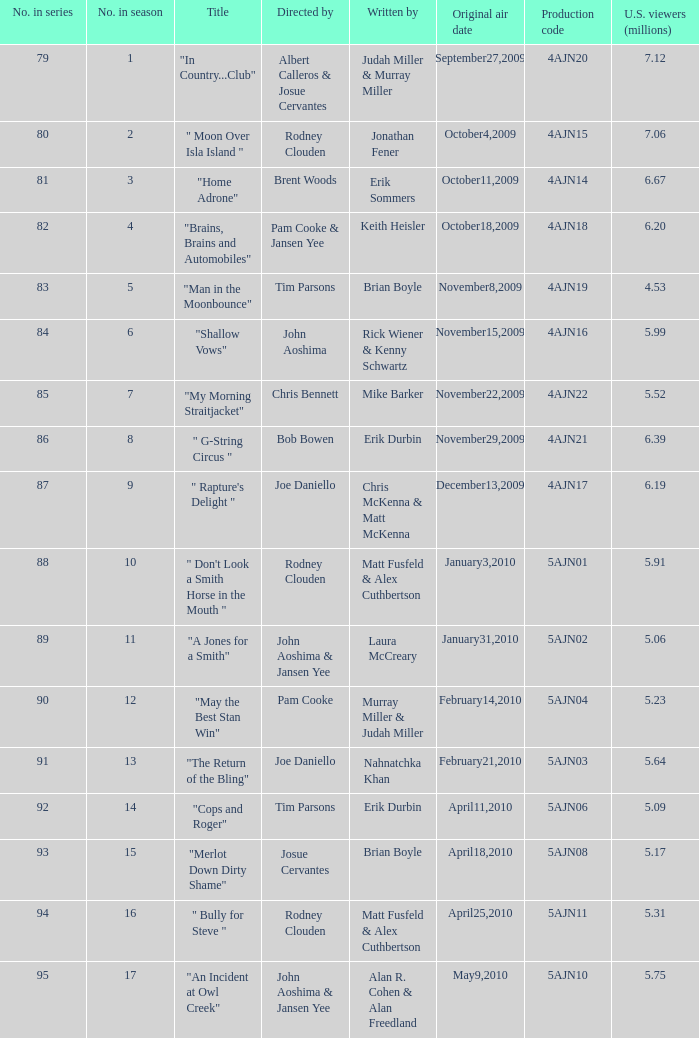Name the original air date for " don't look a smith horse in the mouth " January3,2010. 